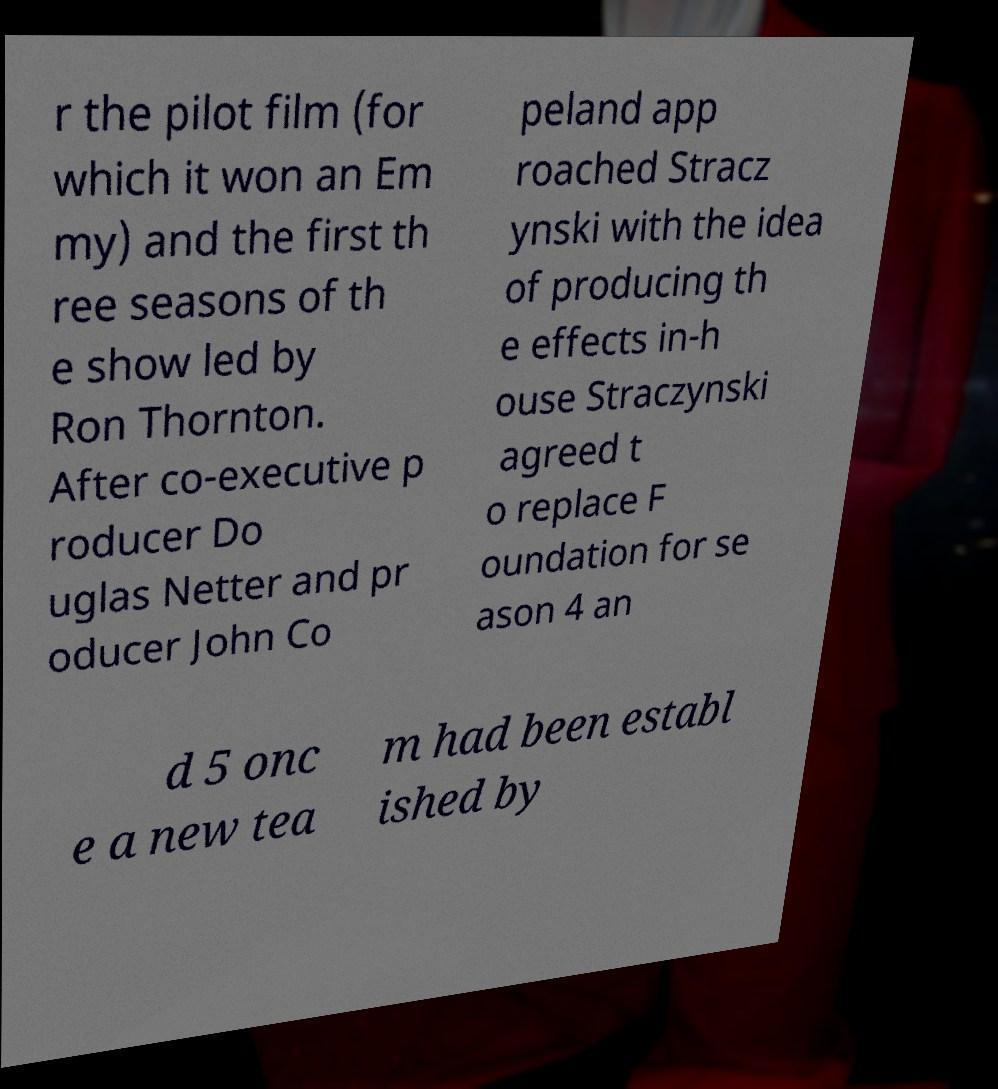For documentation purposes, I need the text within this image transcribed. Could you provide that? r the pilot film (for which it won an Em my) and the first th ree seasons of th e show led by Ron Thornton. After co-executive p roducer Do uglas Netter and pr oducer John Co peland app roached Stracz ynski with the idea of producing th e effects in-h ouse Straczynski agreed t o replace F oundation for se ason 4 an d 5 onc e a new tea m had been establ ished by 